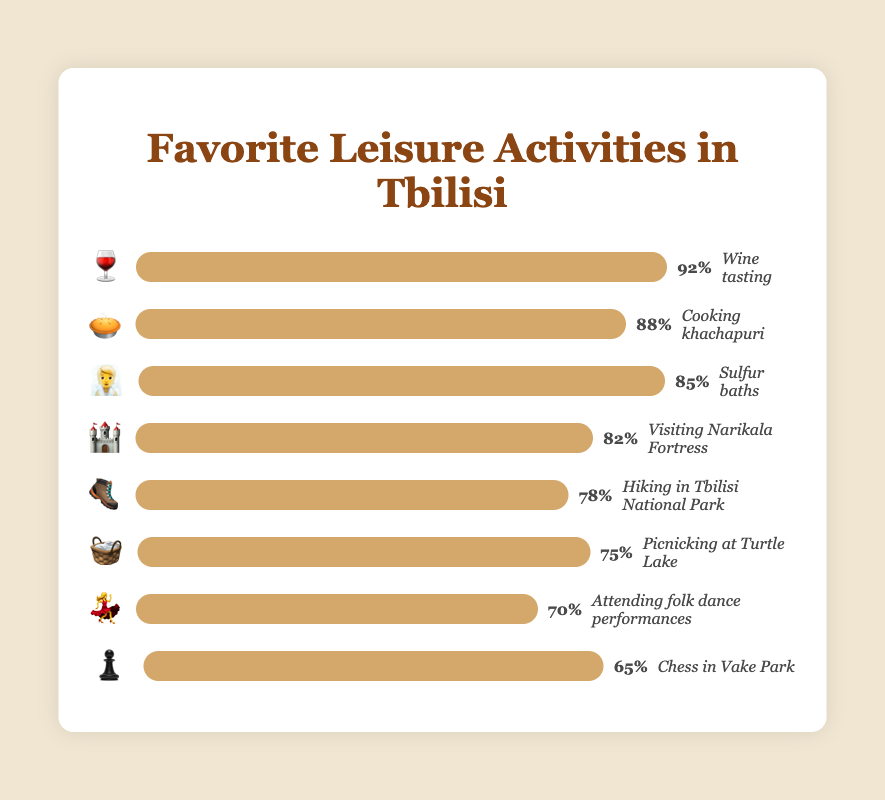what is the most popular activity and its emoji? The figure shows a bar chart with popularity percentages and corresponding emojis for each activity. The most popular activity is "Wine tasting" with a popularity of 92%. This is represented by the 🍷 emoji.
Answer: Wine tasting, 🍷 Which activity is represented by the 🧺 emoji? By looking at the figure, we see that the 🧺 emoji corresponds to the activity "Picnicking at Turtle Lake" with a popularity of 75%.
Answer: Picnicking at Turtle Lake How much more popular is "Cooking khachapuri" compared to "Attending folk dance performances"? "Cooking khachapuri" has a popularity of 88%, and "Attending folk dance performances" has a popularity of 70%. The difference is calculated as 88% - 70% = 18%.
Answer: 18% What is the third most popular leisure activity? The figure ranks activities based on their popularity. The third most popular activity according to the figure is "Sulfur baths" with 85% popularity.
Answer: Sulfur baths Which activity has the lowest popularity and what is its emoji? In the figure, the activity with the lowest popularity is "Chess in Vake Park," which has a popularity of 65%, represented by the ♟️ emoji.
Answer: Chess in Vake Park, ♟️ What is the average popularity of all activities listed? Sum the popularities [92, 88, 85, 82, 78, 75, 70, 65] which equals 635. There are 8 activities, so the average is 635 / 8 = 79.375.
Answer: 79.375 Compare "Hiking in Tbilisi National Park" and "Visiting Narikala Fortress" in terms of popularity and find their difference. "Hiking in Tbilisi National Park" has a popularity of 78% and "Visiting Narikala Fortress" has a popularity of 82%. The difference is 82% - 78% = 4%.
Answer: 4% How many activities have a popularity of 80% or higher? The activities with 80% or higher popularity are "Wine tasting" (92%), "Cooking khachapuri" (88%), "Sulfur baths" (85%), and "Visiting Narikala Fortress" (82%). There are 4 such activities.
Answer: 4 What is the median popularity of the activities? List the popularities in ascending order: [65, 70, 75, 78, 82, 85, 88, 92]. The median is the average of the 4th and 5th values: (78 + 82) / 2 = 80%.
Answer: 80% Which activity is represented by the most popular emoji 🍷 and what is its popularity? The figure shows that 🍷 corresponds to "Wine tasting" which has the highest popularity of 92%.
Answer: Wine tasting, 92% 